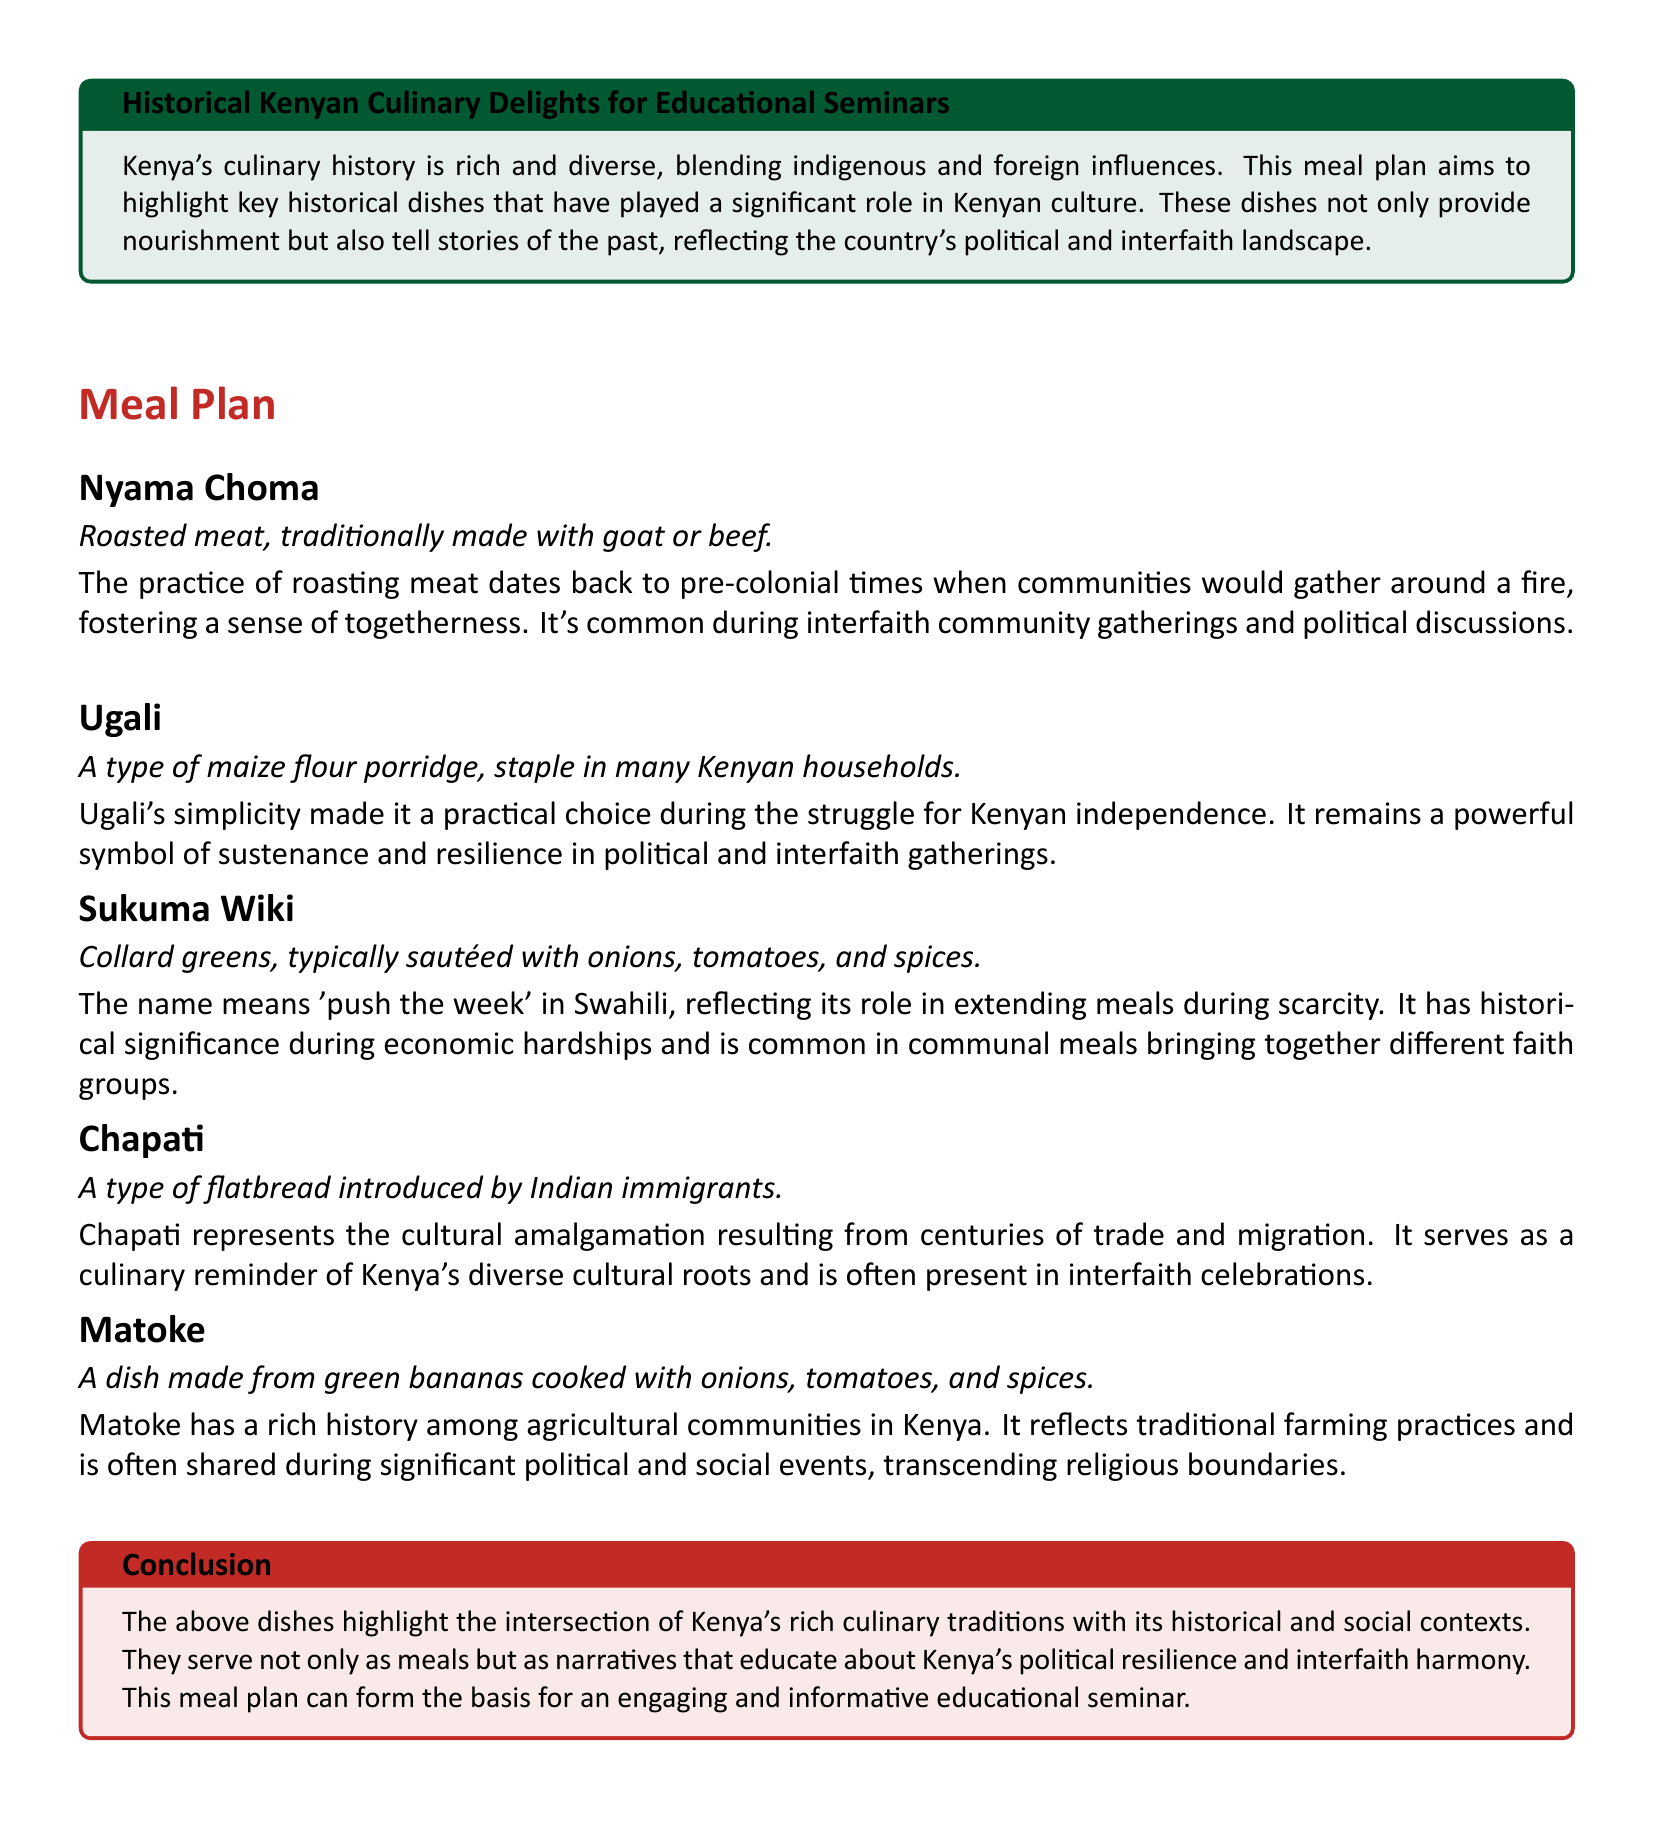What dish symbolizes sustenance and resilience? The document states that Ugali remains a powerful symbol of sustenance and resilience in political and interfaith gatherings.
Answer: Ugali What is Nyama Choma traditionally made with? The document mentions that Nyama Choma is traditionally made with goat or beef.
Answer: Goat or beef What does Sukuma Wiki mean in Swahili? The document explains that Sukuma Wiki means 'push the week' in Swahili.
Answer: Push the week Which dish represents cultural amalgamation from trade and migration? According to the document, Chapati represents the cultural amalgamation resulting from centuries of trade and migration.
Answer: Chapati What type of vegetable is used in Sukuma Wiki? The document specifies that collard greens are used in Sukuma Wiki.
Answer: Collard greens Which dish has historical significance during economic hardships? The document states that Sukuma Wiki has historical significance during economic hardships.
Answer: Sukuma Wiki What dish is cooked with green bananas? Matoke is the dish that is made from green bananas cooked with onions, tomatoes, and spices.
Answer: Matoke Which community gatherings is Nyama Choma common in? The document indicates that Nyama Choma is common during interfaith community gatherings and political discussions.
Answer: Interfaith community gatherings What represents traditional farming practices in Kenya? The document asserts that Matoke reflects traditional farming practices and is often shared during significant political and social events.
Answer: Matoke 